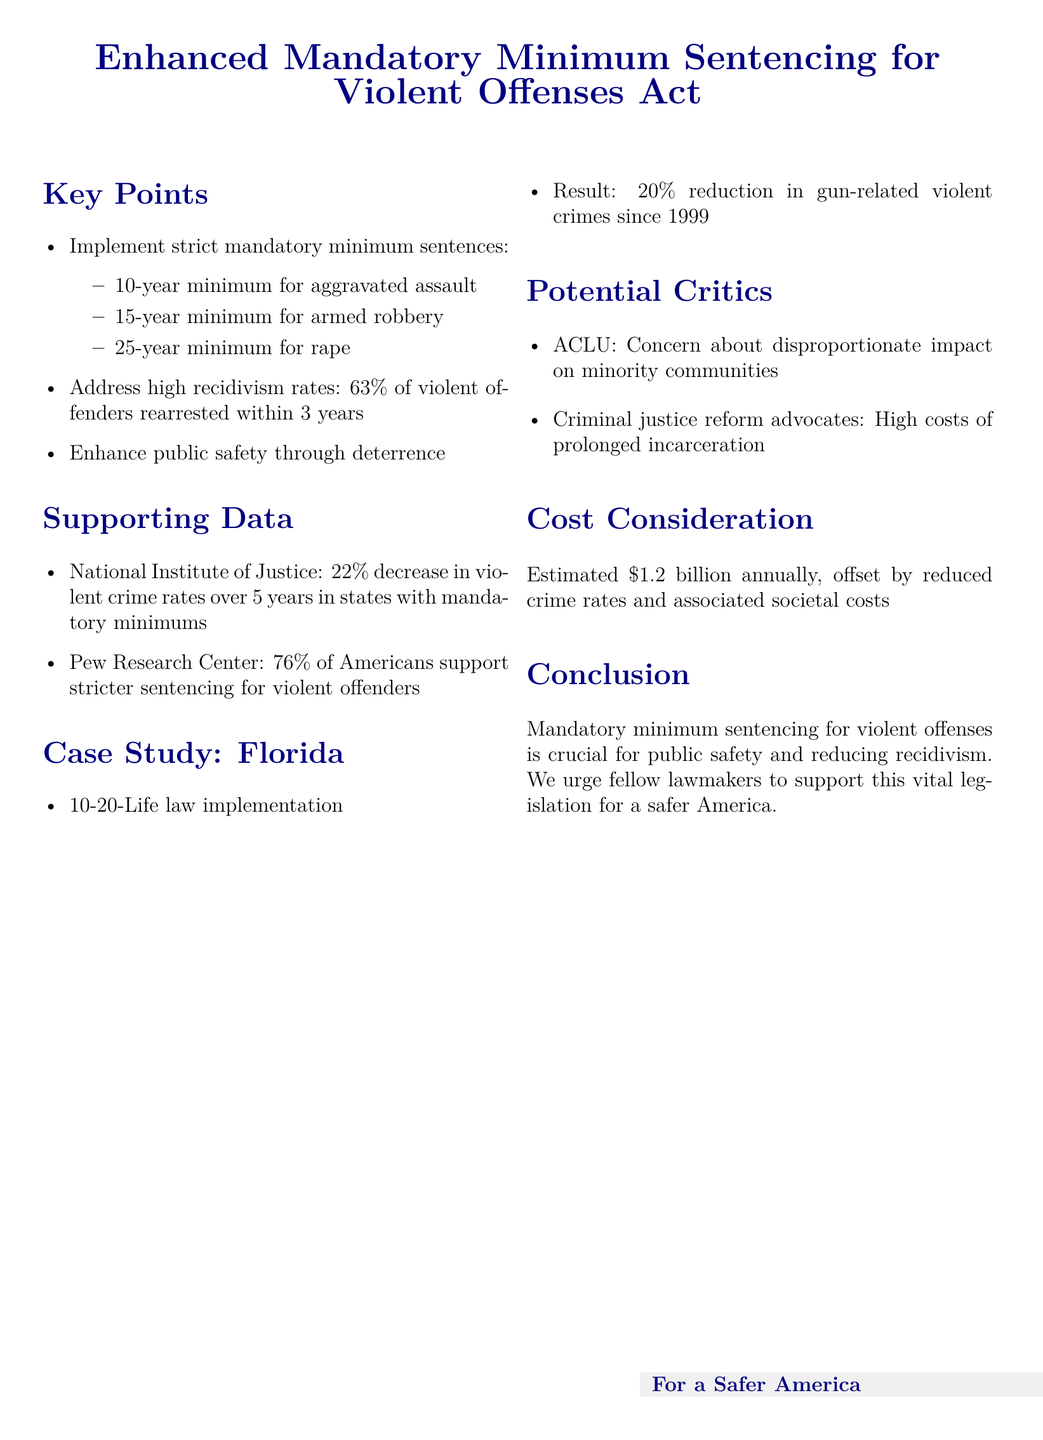What is the proposed minimum sentence for armed robbery? The document states the proposed minimum sentence for armed robbery is 15 years.
Answer: 15-year minimum What percentage of violent offenders are rearrested within 3 years? The document mentions that 63% of violent offenders are rearrested within 3 years.
Answer: 63% What was the decrease in violent crime rates over 5 years in states with mandatory minimums? The document cites a 22% decrease in violent crime rates over 5 years in states with mandatory minimums.
Answer: 22% What is the estimated annual cost of implementing the proposal? The document lists the estimated annual cost of implementing the proposal as $1.2 billion.
Answer: $1.2 billion What law did Florida implement related to sentencing? The document references Florida's 10-20-Life law as significant in its sentencing practices.
Answer: 10-20-Life law What did 76% of Americans support regarding sentencing for violent offenders? According to the document, 76% of Americans support stricter sentencing for violent offenders.
Answer: Stricter sentencing What impact did the 10-20-Life law have on gun-related violent crimes since 1999? The document states that the law resulted in a 20% reduction in gun-related violent crimes since 1999.
Answer: 20% reduction Who expressed concern about the proposal's impact on minority communities? The ACLU is mentioned as expressing concern about the disproportionate impact on minority communities.
Answer: ACLU What is the primary goal of the Enhanced Mandatory Minimum Sentencing for Violent Offenses Act? The document emphasizes that the primary goal is public safety and reducing recidivism.
Answer: Public safety and reducing recidivism 